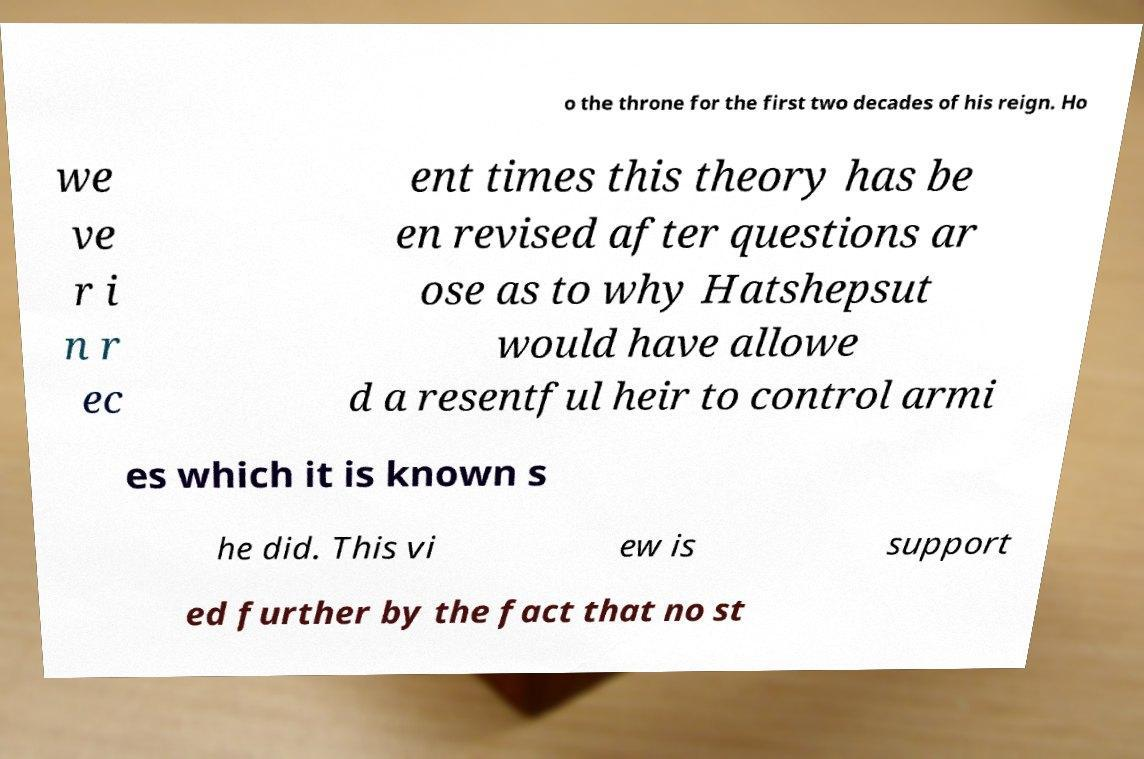What messages or text are displayed in this image? I need them in a readable, typed format. o the throne for the first two decades of his reign. Ho we ve r i n r ec ent times this theory has be en revised after questions ar ose as to why Hatshepsut would have allowe d a resentful heir to control armi es which it is known s he did. This vi ew is support ed further by the fact that no st 